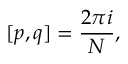<formula> <loc_0><loc_0><loc_500><loc_500>[ p , q ] = \frac { 2 \pi i } { N } ,</formula> 